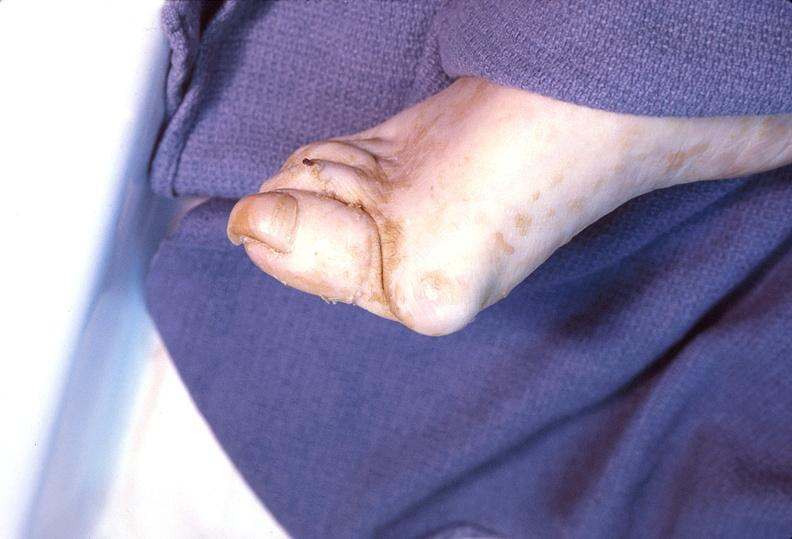s musculoskeletal present?
Answer the question using a single word or phrase. Yes 